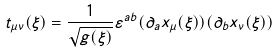<formula> <loc_0><loc_0><loc_500><loc_500>t _ { \mu \nu } ( \xi ) = \frac { 1 } { \sqrt { g ( \xi ) } } \varepsilon ^ { a b } ( \partial _ { a } x _ { \mu } ( \xi ) ) ( \partial _ { b } x _ { \nu } ( \xi ) )</formula> 